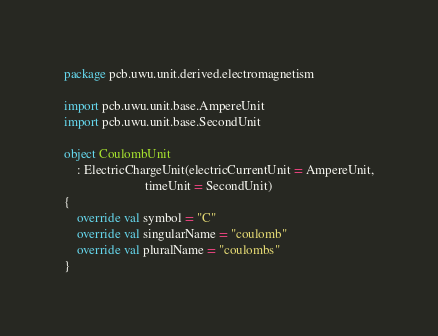Convert code to text. <code><loc_0><loc_0><loc_500><loc_500><_Kotlin_>package pcb.uwu.unit.derived.electromagnetism

import pcb.uwu.unit.base.AmpereUnit
import pcb.uwu.unit.base.SecondUnit

object CoulombUnit
    : ElectricChargeUnit(electricCurrentUnit = AmpereUnit,
                         timeUnit = SecondUnit)
{
    override val symbol = "C"
    override val singularName = "coulomb"
    override val pluralName = "coulombs"
}
</code> 